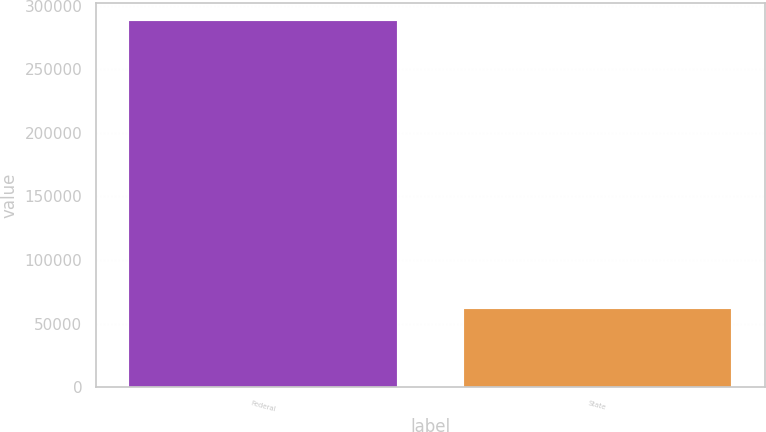<chart> <loc_0><loc_0><loc_500><loc_500><bar_chart><fcel>Federal<fcel>State<nl><fcel>288069<fcel>61503<nl></chart> 